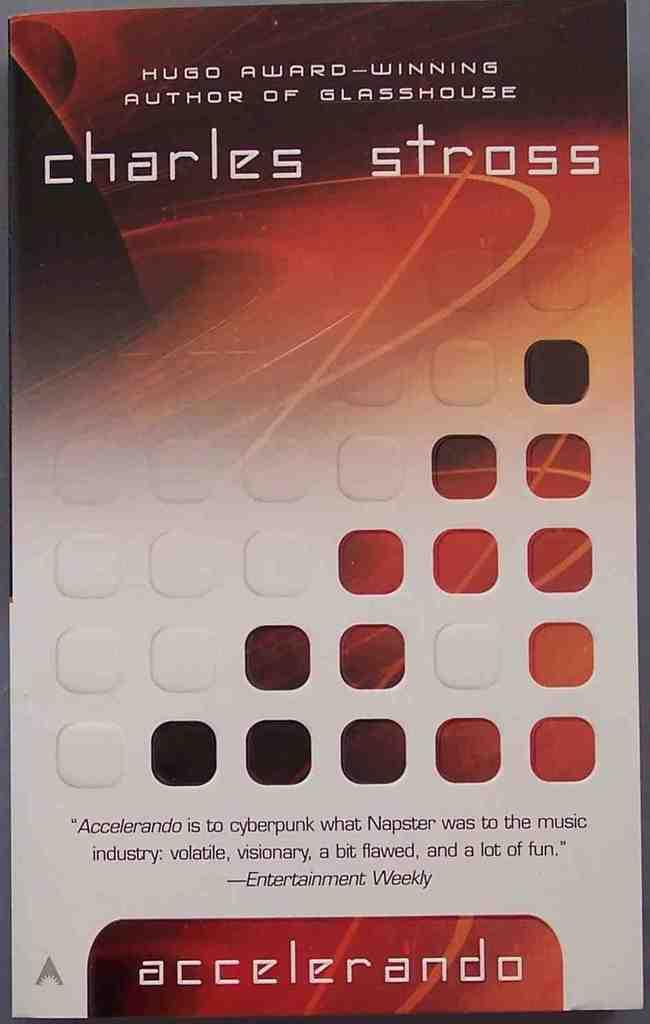<image>
Present a compact description of the photo's key features. The front page of a book, accelerando by charles stross, with a review by entertainment weekly. 